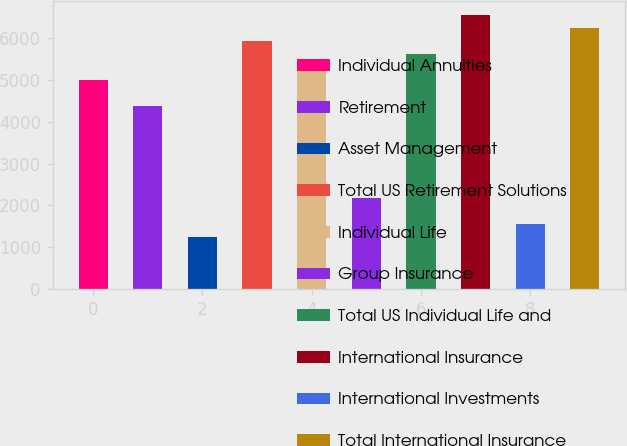Convert chart. <chart><loc_0><loc_0><loc_500><loc_500><bar_chart><fcel>Individual Annuities<fcel>Retirement<fcel>Asset Management<fcel>Total US Retirement Solutions<fcel>Individual Life<fcel>Group Insurance<fcel>Total US Individual Life and<fcel>International Insurance<fcel>International Investments<fcel>Total International Insurance<nl><fcel>4996.92<fcel>4372.62<fcel>1251.12<fcel>5933.37<fcel>5309.07<fcel>2187.57<fcel>5621.22<fcel>6557.67<fcel>1563.27<fcel>6245.52<nl></chart> 